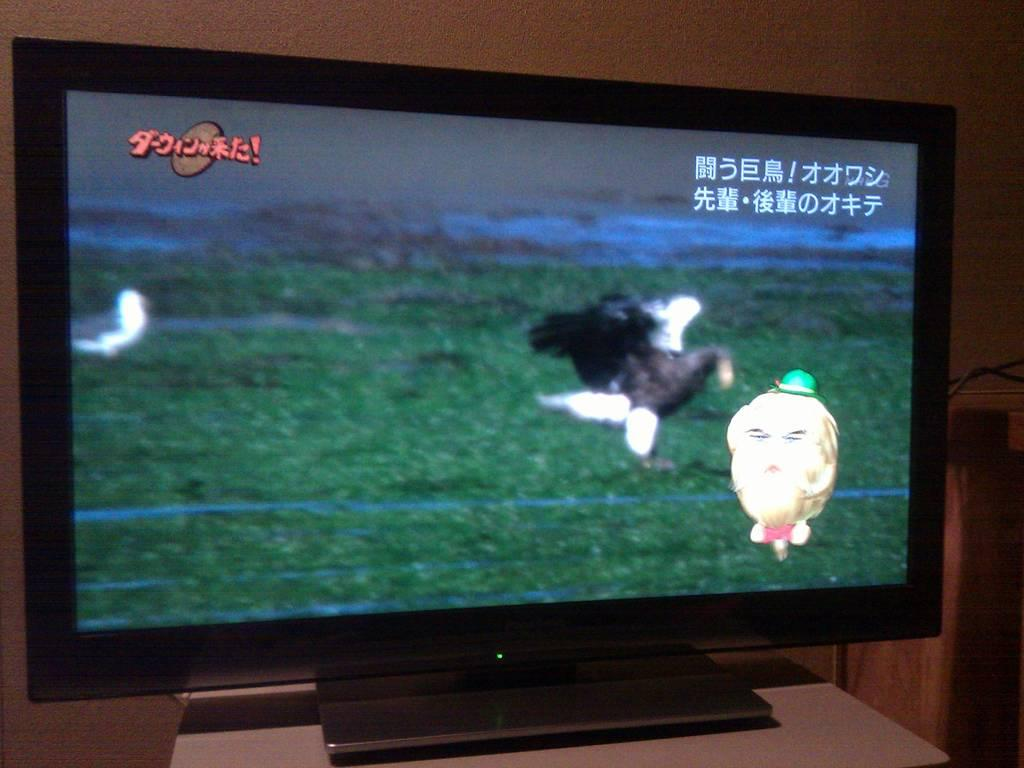What is on the table in the image? There is a television on the table. What can be seen in the background of the image? There is a wall in the background of the image. What is being displayed on the television screen? Birds and a cartoon image are visible on the television screen. What is the price of the clam being sold on the television screen? There is no clam being sold on the television screen; it displays birds and a cartoon image. 